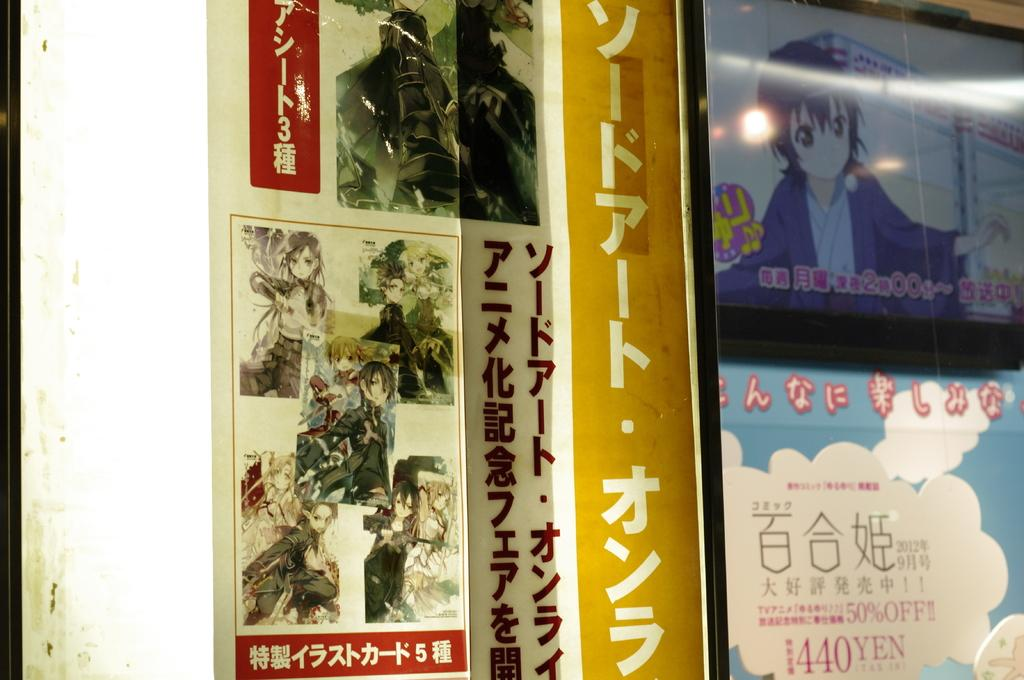<image>
Write a terse but informative summary of the picture. Multiple Chinese cartoon displays with a sign offering 50% off. 